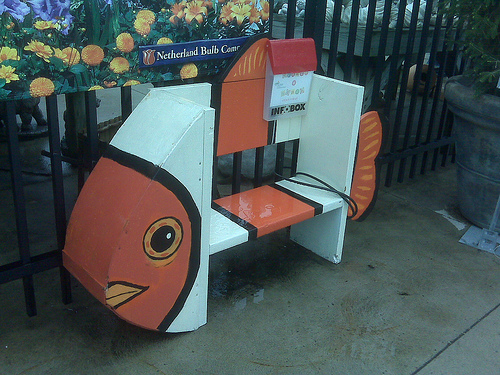<image>
Is the bench to the right of the fish head? Yes. From this viewpoint, the bench is positioned to the right side relative to the fish head. 